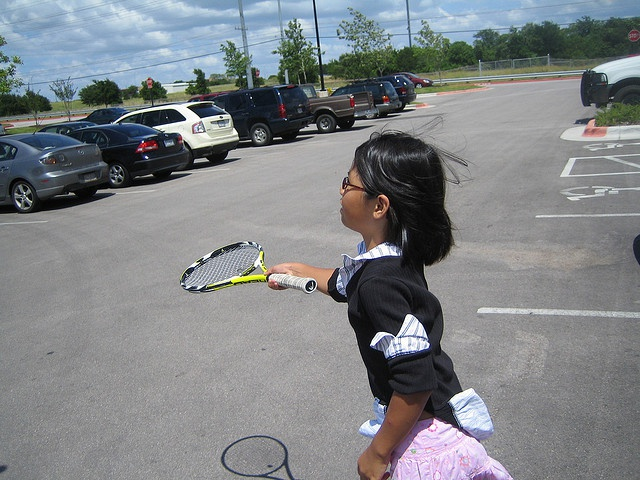Describe the objects in this image and their specific colors. I can see people in darkgray, black, lavender, and gray tones, car in darkgray, black, gray, and darkblue tones, car in darkgray, black, navy, darkblue, and gray tones, car in darkgray, black, ivory, and navy tones, and car in darkgray, black, navy, gray, and darkblue tones in this image. 